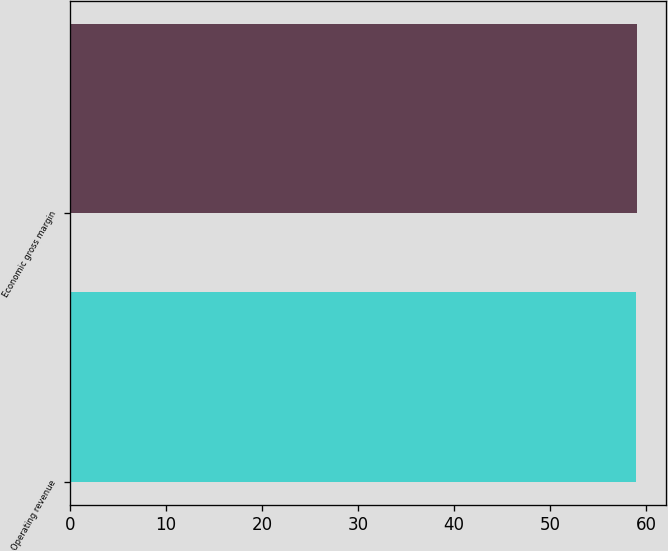Convert chart to OTSL. <chart><loc_0><loc_0><loc_500><loc_500><bar_chart><fcel>Operating revenue<fcel>Economic gross margin<nl><fcel>59<fcel>59.1<nl></chart> 